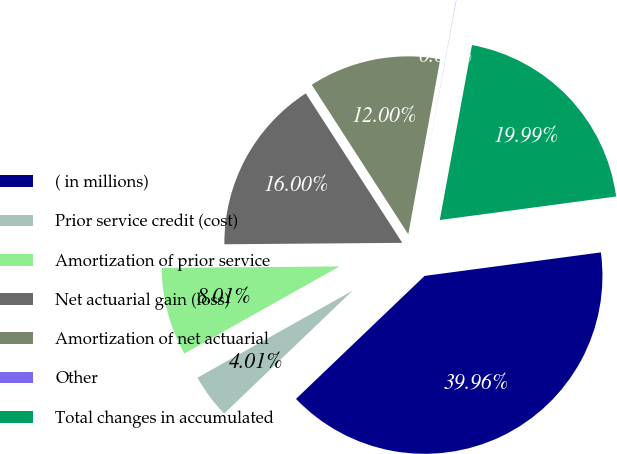<chart> <loc_0><loc_0><loc_500><loc_500><pie_chart><fcel>( in millions)<fcel>Prior service credit (cost)<fcel>Amortization of prior service<fcel>Net actuarial gain (loss)<fcel>Amortization of net actuarial<fcel>Other<fcel>Total changes in accumulated<nl><fcel>39.96%<fcel>4.01%<fcel>8.01%<fcel>16.0%<fcel>12.0%<fcel>0.02%<fcel>19.99%<nl></chart> 